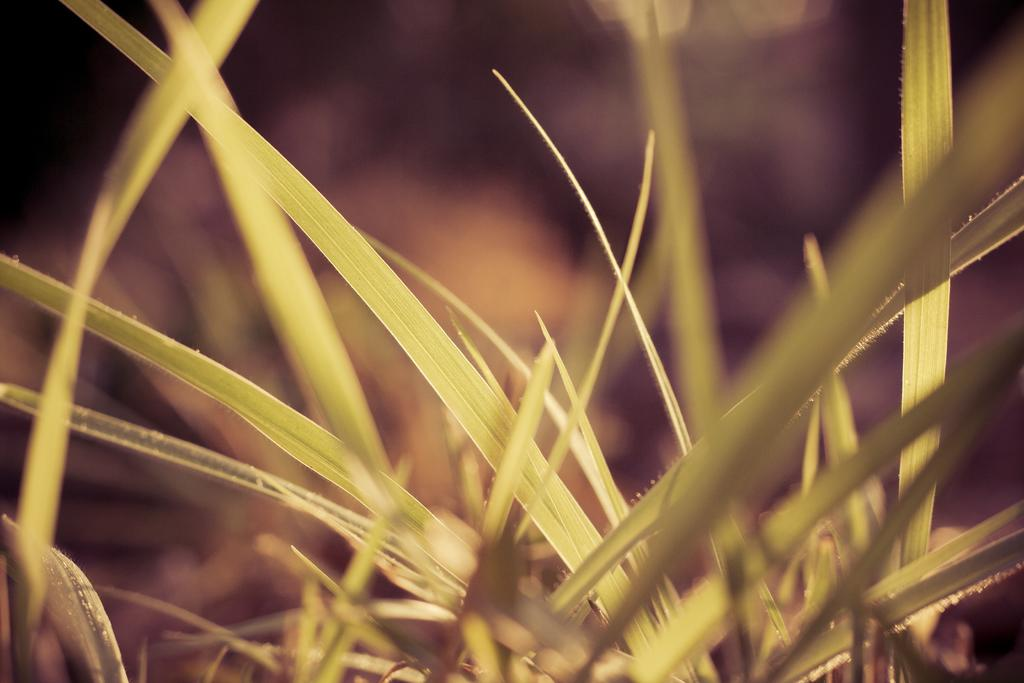What is visible in the foreground of the image? There are leaves in the foreground of the image. What type of jam is being spread on the coach in the image? There is no jam or coach present in the image; it only features leaves in the foreground. What insect can be seen crawling on the leaves in the image? There is no insect visible on the leaves in the image. 